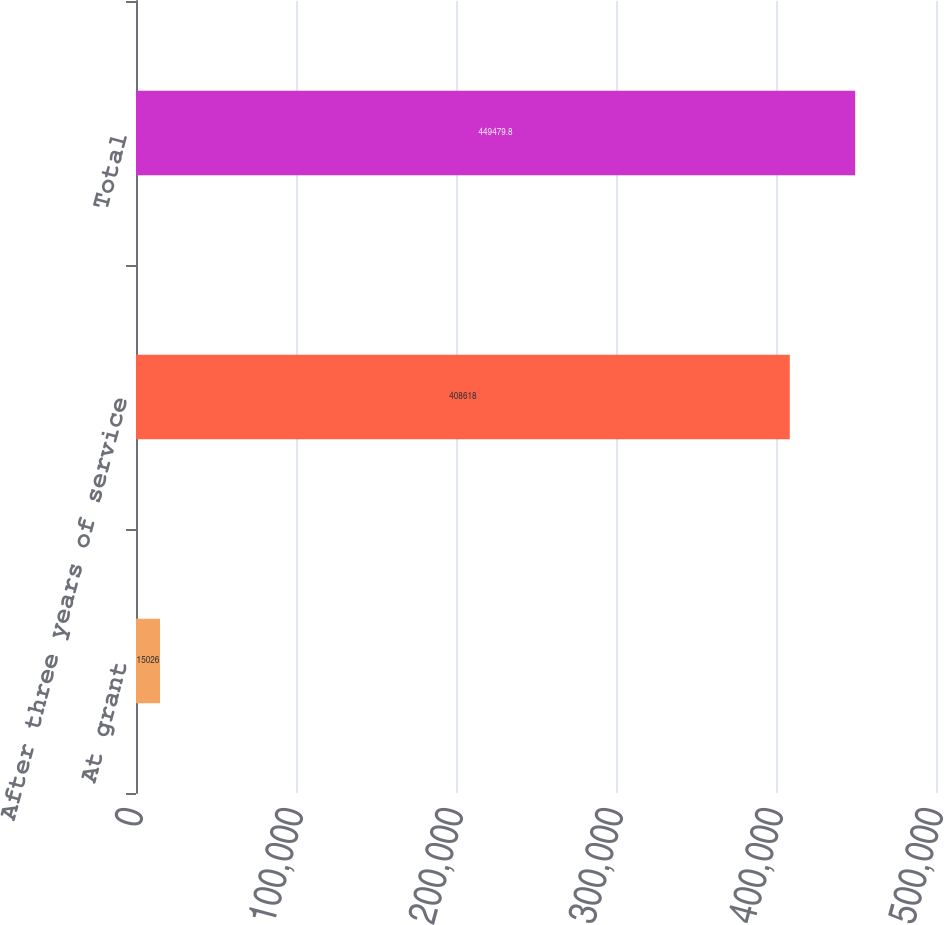Convert chart. <chart><loc_0><loc_0><loc_500><loc_500><bar_chart><fcel>At grant<fcel>After three years of service<fcel>Total<nl><fcel>15026<fcel>408618<fcel>449480<nl></chart> 